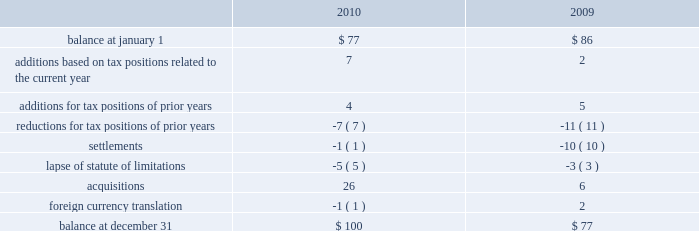Remitted to the u.s .
Due to foreign tax credits and exclusions that may become available at the time of remittance .
At december 31 , 2010 , aon had domestic federal operating loss carryforwards of $ 56 million that will expire at various dates from 2011 to 2024 , state operating loss carryforwards of $ 610 million that will expire at various dates from 2011 to 2031 , and foreign operating and capital loss carryforwards of $ 720 million and $ 251 million , respectively , nearly all of which are subject to indefinite carryforward .
Unrecognized tax provisions the following is a reconciliation of the company 2019s beginning and ending amount of unrecognized tax benefits ( in millions ) : .
As of december 31 , 2010 , $ 85 million of unrecognized tax benefits would impact the effective tax rate if recognized .
Aon does not expect the unrecognized tax positions to change significantly over the next twelve months , except for a potential reduction of unrecognized tax benefits in the range of $ 10-$ 15 million relating to anticipated audit settlements .
The company recognizes penalties and interest related to unrecognized income tax benefits in its provision for income taxes .
Aon accrued potential penalties of less than $ 1 million during each of 2010 , 2009 and 2008 .
Aon accrued interest of less than $ 1 million in 2010 , $ 2 million during 2009 and less than $ 1 million in 2008 .
Aon has recorded a liability for penalties of $ 5 million and for interest of $ 18 million for both december 31 , 2010 and 2009 .
Aon and its subsidiaries file income tax returns in the u.s .
Federal jurisdiction as well as various state and international jurisdictions .
Aon has substantially concluded all u.s .
Federal income tax matters for years through 2006 .
Material u.s .
State and local income tax jurisdiction examinations have been concluded for years through 2002 .
Aon has concluded income tax examinations in its primary international jurisdictions through 2004. .
What was the average accrued interest by aon from 2009 to 2010 in millions? 
Computations: (((1 + 2) + 2) / 2)
Answer: 2.5. Remitted to the u.s .
Due to foreign tax credits and exclusions that may become available at the time of remittance .
At december 31 , 2010 , aon had domestic federal operating loss carryforwards of $ 56 million that will expire at various dates from 2011 to 2024 , state operating loss carryforwards of $ 610 million that will expire at various dates from 2011 to 2031 , and foreign operating and capital loss carryforwards of $ 720 million and $ 251 million , respectively , nearly all of which are subject to indefinite carryforward .
Unrecognized tax provisions the following is a reconciliation of the company 2019s beginning and ending amount of unrecognized tax benefits ( in millions ) : .
As of december 31 , 2010 , $ 85 million of unrecognized tax benefits would impact the effective tax rate if recognized .
Aon does not expect the unrecognized tax positions to change significantly over the next twelve months , except for a potential reduction of unrecognized tax benefits in the range of $ 10-$ 15 million relating to anticipated audit settlements .
The company recognizes penalties and interest related to unrecognized income tax benefits in its provision for income taxes .
Aon accrued potential penalties of less than $ 1 million during each of 2010 , 2009 and 2008 .
Aon accrued interest of less than $ 1 million in 2010 , $ 2 million during 2009 and less than $ 1 million in 2008 .
Aon has recorded a liability for penalties of $ 5 million and for interest of $ 18 million for both december 31 , 2010 and 2009 .
Aon and its subsidiaries file income tax returns in the u.s .
Federal jurisdiction as well as various state and international jurisdictions .
Aon has substantially concluded all u.s .
Federal income tax matters for years through 2006 .
Material u.s .
State and local income tax jurisdiction examinations have been concluded for years through 2002 .
Aon has concluded income tax examinations in its primary international jurisdictions through 2004. .
What was the percentage change in the unrecognized tax provisions in 2010? 
Computations: (100 - 77)
Answer: 23.0. 